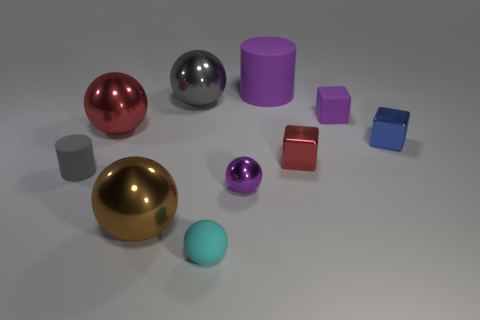Is there a red shiny object of the same shape as the brown shiny object?
Make the answer very short. Yes. There is a small sphere that is left of the small shiny object to the left of the matte cylinder that is right of the tiny purple metal thing; what is its material?
Provide a succinct answer. Rubber. How many other objects are there of the same size as the cyan sphere?
Give a very brief answer. 5. What color is the big cylinder?
Give a very brief answer. Purple. What number of shiny things are red objects or purple spheres?
Offer a terse response. 3. There is a metallic object to the right of the small purple object behind the matte cylinder that is in front of the purple rubber cylinder; how big is it?
Provide a succinct answer. Small. What size is the matte object that is both behind the cyan matte ball and in front of the blue shiny object?
Make the answer very short. Small. There is a tiny ball behind the brown metallic sphere; does it have the same color as the big object that is behind the gray shiny ball?
Offer a terse response. Yes. There is a small purple matte thing; what number of objects are in front of it?
Your response must be concise. 7. There is a rubber cylinder right of the small thing to the left of the small cyan object; are there any red metallic things to the right of it?
Offer a terse response. Yes. 